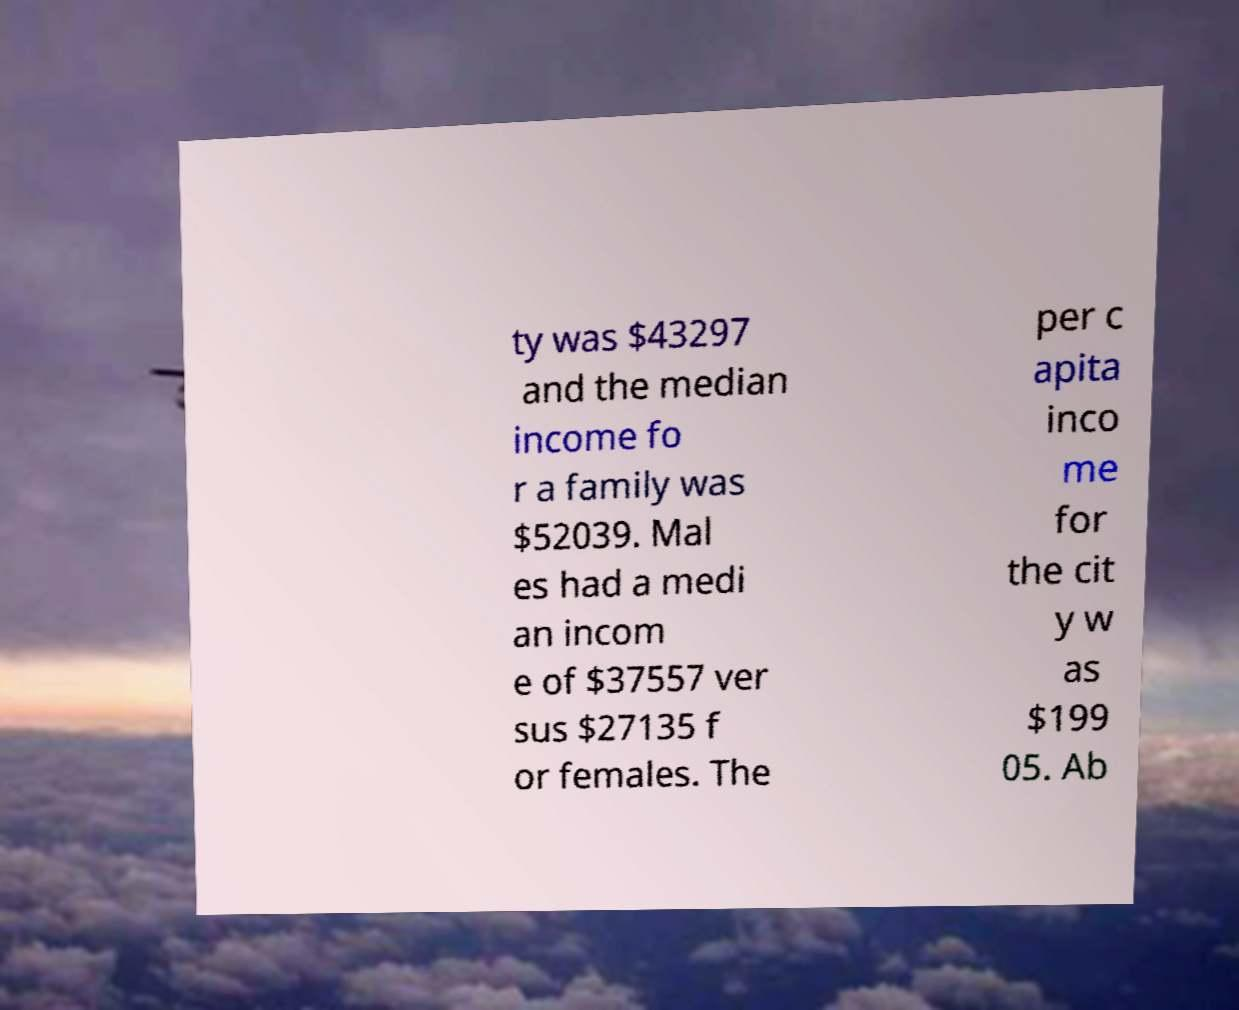Could you extract and type out the text from this image? ty was $43297 and the median income fo r a family was $52039. Mal es had a medi an incom e of $37557 ver sus $27135 f or females. The per c apita inco me for the cit y w as $199 05. Ab 